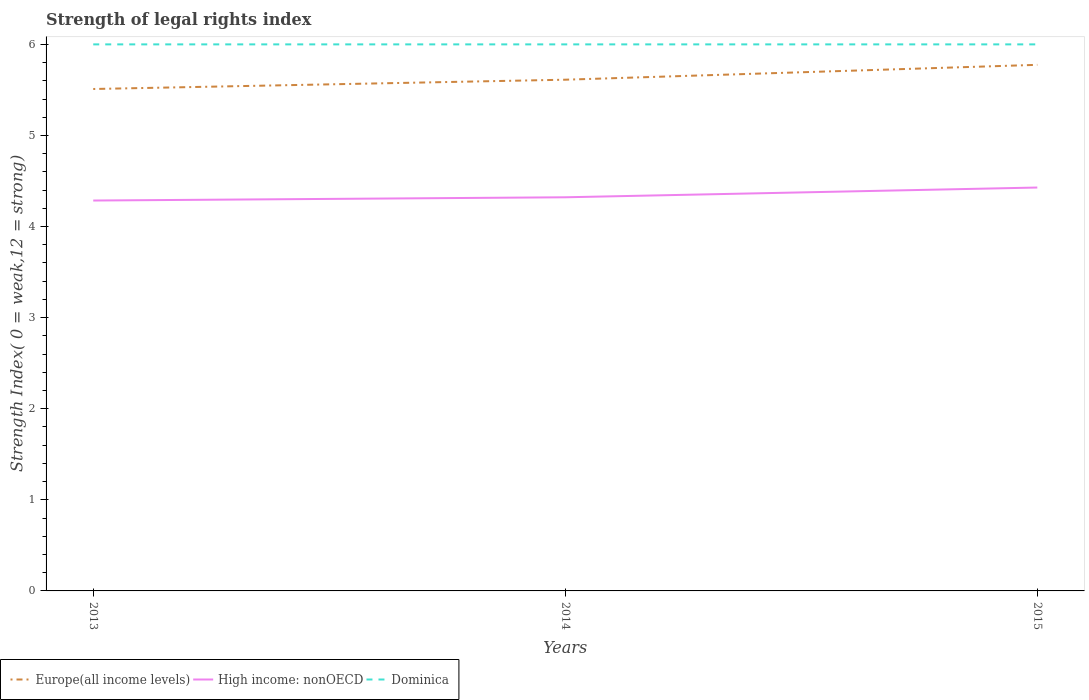Is the number of lines equal to the number of legend labels?
Your answer should be compact. Yes. Across all years, what is the maximum strength index in Europe(all income levels)?
Keep it short and to the point. 5.51. In which year was the strength index in Dominica maximum?
Provide a short and direct response. 2013. What is the total strength index in High income: nonOECD in the graph?
Your response must be concise. -0.04. What is the difference between the highest and the second highest strength index in High income: nonOECD?
Your answer should be very brief. 0.14. Is the strength index in Europe(all income levels) strictly greater than the strength index in High income: nonOECD over the years?
Provide a short and direct response. No. How many lines are there?
Your answer should be compact. 3. How many years are there in the graph?
Offer a very short reply. 3. Does the graph contain grids?
Offer a terse response. No. What is the title of the graph?
Your answer should be compact. Strength of legal rights index. What is the label or title of the X-axis?
Offer a terse response. Years. What is the label or title of the Y-axis?
Provide a succinct answer. Strength Index( 0 = weak,12 = strong). What is the Strength Index( 0 = weak,12 = strong) in Europe(all income levels) in 2013?
Offer a terse response. 5.51. What is the Strength Index( 0 = weak,12 = strong) in High income: nonOECD in 2013?
Your response must be concise. 4.29. What is the Strength Index( 0 = weak,12 = strong) in Europe(all income levels) in 2014?
Your answer should be compact. 5.61. What is the Strength Index( 0 = weak,12 = strong) in High income: nonOECD in 2014?
Your answer should be very brief. 4.32. What is the Strength Index( 0 = weak,12 = strong) in Europe(all income levels) in 2015?
Keep it short and to the point. 5.78. What is the Strength Index( 0 = weak,12 = strong) of High income: nonOECD in 2015?
Offer a very short reply. 4.43. What is the Strength Index( 0 = weak,12 = strong) of Dominica in 2015?
Give a very brief answer. 6. Across all years, what is the maximum Strength Index( 0 = weak,12 = strong) of Europe(all income levels)?
Offer a very short reply. 5.78. Across all years, what is the maximum Strength Index( 0 = weak,12 = strong) in High income: nonOECD?
Ensure brevity in your answer.  4.43. Across all years, what is the maximum Strength Index( 0 = weak,12 = strong) of Dominica?
Provide a short and direct response. 6. Across all years, what is the minimum Strength Index( 0 = weak,12 = strong) in Europe(all income levels)?
Keep it short and to the point. 5.51. Across all years, what is the minimum Strength Index( 0 = weak,12 = strong) in High income: nonOECD?
Your response must be concise. 4.29. Across all years, what is the minimum Strength Index( 0 = weak,12 = strong) of Dominica?
Offer a terse response. 6. What is the total Strength Index( 0 = weak,12 = strong) in Europe(all income levels) in the graph?
Provide a short and direct response. 16.9. What is the total Strength Index( 0 = weak,12 = strong) of High income: nonOECD in the graph?
Provide a short and direct response. 13.04. What is the total Strength Index( 0 = weak,12 = strong) of Dominica in the graph?
Your response must be concise. 18. What is the difference between the Strength Index( 0 = weak,12 = strong) in Europe(all income levels) in 2013 and that in 2014?
Offer a very short reply. -0.1. What is the difference between the Strength Index( 0 = weak,12 = strong) of High income: nonOECD in 2013 and that in 2014?
Offer a terse response. -0.04. What is the difference between the Strength Index( 0 = weak,12 = strong) of Europe(all income levels) in 2013 and that in 2015?
Provide a succinct answer. -0.27. What is the difference between the Strength Index( 0 = weak,12 = strong) of High income: nonOECD in 2013 and that in 2015?
Offer a very short reply. -0.14. What is the difference between the Strength Index( 0 = weak,12 = strong) in Dominica in 2013 and that in 2015?
Keep it short and to the point. 0. What is the difference between the Strength Index( 0 = weak,12 = strong) of Europe(all income levels) in 2014 and that in 2015?
Your answer should be compact. -0.16. What is the difference between the Strength Index( 0 = weak,12 = strong) of High income: nonOECD in 2014 and that in 2015?
Keep it short and to the point. -0.11. What is the difference between the Strength Index( 0 = weak,12 = strong) of Dominica in 2014 and that in 2015?
Give a very brief answer. 0. What is the difference between the Strength Index( 0 = weak,12 = strong) of Europe(all income levels) in 2013 and the Strength Index( 0 = weak,12 = strong) of High income: nonOECD in 2014?
Your response must be concise. 1.19. What is the difference between the Strength Index( 0 = weak,12 = strong) in Europe(all income levels) in 2013 and the Strength Index( 0 = weak,12 = strong) in Dominica in 2014?
Your response must be concise. -0.49. What is the difference between the Strength Index( 0 = weak,12 = strong) of High income: nonOECD in 2013 and the Strength Index( 0 = weak,12 = strong) of Dominica in 2014?
Offer a terse response. -1.71. What is the difference between the Strength Index( 0 = weak,12 = strong) in Europe(all income levels) in 2013 and the Strength Index( 0 = weak,12 = strong) in High income: nonOECD in 2015?
Provide a short and direct response. 1.08. What is the difference between the Strength Index( 0 = weak,12 = strong) of Europe(all income levels) in 2013 and the Strength Index( 0 = weak,12 = strong) of Dominica in 2015?
Your response must be concise. -0.49. What is the difference between the Strength Index( 0 = weak,12 = strong) in High income: nonOECD in 2013 and the Strength Index( 0 = weak,12 = strong) in Dominica in 2015?
Offer a terse response. -1.71. What is the difference between the Strength Index( 0 = weak,12 = strong) of Europe(all income levels) in 2014 and the Strength Index( 0 = weak,12 = strong) of High income: nonOECD in 2015?
Keep it short and to the point. 1.18. What is the difference between the Strength Index( 0 = weak,12 = strong) in Europe(all income levels) in 2014 and the Strength Index( 0 = weak,12 = strong) in Dominica in 2015?
Your response must be concise. -0.39. What is the difference between the Strength Index( 0 = weak,12 = strong) in High income: nonOECD in 2014 and the Strength Index( 0 = weak,12 = strong) in Dominica in 2015?
Offer a terse response. -1.68. What is the average Strength Index( 0 = weak,12 = strong) in Europe(all income levels) per year?
Your answer should be very brief. 5.63. What is the average Strength Index( 0 = weak,12 = strong) of High income: nonOECD per year?
Provide a short and direct response. 4.35. In the year 2013, what is the difference between the Strength Index( 0 = weak,12 = strong) of Europe(all income levels) and Strength Index( 0 = weak,12 = strong) of High income: nonOECD?
Make the answer very short. 1.22. In the year 2013, what is the difference between the Strength Index( 0 = weak,12 = strong) in Europe(all income levels) and Strength Index( 0 = weak,12 = strong) in Dominica?
Make the answer very short. -0.49. In the year 2013, what is the difference between the Strength Index( 0 = weak,12 = strong) in High income: nonOECD and Strength Index( 0 = weak,12 = strong) in Dominica?
Your response must be concise. -1.71. In the year 2014, what is the difference between the Strength Index( 0 = weak,12 = strong) in Europe(all income levels) and Strength Index( 0 = weak,12 = strong) in High income: nonOECD?
Keep it short and to the point. 1.29. In the year 2014, what is the difference between the Strength Index( 0 = weak,12 = strong) in Europe(all income levels) and Strength Index( 0 = weak,12 = strong) in Dominica?
Provide a succinct answer. -0.39. In the year 2014, what is the difference between the Strength Index( 0 = weak,12 = strong) in High income: nonOECD and Strength Index( 0 = weak,12 = strong) in Dominica?
Provide a succinct answer. -1.68. In the year 2015, what is the difference between the Strength Index( 0 = weak,12 = strong) of Europe(all income levels) and Strength Index( 0 = weak,12 = strong) of High income: nonOECD?
Your response must be concise. 1.35. In the year 2015, what is the difference between the Strength Index( 0 = weak,12 = strong) of Europe(all income levels) and Strength Index( 0 = weak,12 = strong) of Dominica?
Provide a short and direct response. -0.22. In the year 2015, what is the difference between the Strength Index( 0 = weak,12 = strong) of High income: nonOECD and Strength Index( 0 = weak,12 = strong) of Dominica?
Ensure brevity in your answer.  -1.57. What is the ratio of the Strength Index( 0 = weak,12 = strong) in Europe(all income levels) in 2013 to that in 2014?
Make the answer very short. 0.98. What is the ratio of the Strength Index( 0 = weak,12 = strong) of High income: nonOECD in 2013 to that in 2014?
Offer a very short reply. 0.99. What is the ratio of the Strength Index( 0 = weak,12 = strong) of Europe(all income levels) in 2013 to that in 2015?
Ensure brevity in your answer.  0.95. What is the ratio of the Strength Index( 0 = weak,12 = strong) of High income: nonOECD in 2013 to that in 2015?
Provide a short and direct response. 0.97. What is the ratio of the Strength Index( 0 = weak,12 = strong) in Dominica in 2013 to that in 2015?
Offer a very short reply. 1. What is the ratio of the Strength Index( 0 = weak,12 = strong) in Europe(all income levels) in 2014 to that in 2015?
Make the answer very short. 0.97. What is the ratio of the Strength Index( 0 = weak,12 = strong) in High income: nonOECD in 2014 to that in 2015?
Make the answer very short. 0.98. What is the difference between the highest and the second highest Strength Index( 0 = weak,12 = strong) of Europe(all income levels)?
Provide a succinct answer. 0.16. What is the difference between the highest and the second highest Strength Index( 0 = weak,12 = strong) in High income: nonOECD?
Your answer should be compact. 0.11. What is the difference between the highest and the lowest Strength Index( 0 = weak,12 = strong) of Europe(all income levels)?
Ensure brevity in your answer.  0.27. What is the difference between the highest and the lowest Strength Index( 0 = weak,12 = strong) in High income: nonOECD?
Provide a short and direct response. 0.14. What is the difference between the highest and the lowest Strength Index( 0 = weak,12 = strong) in Dominica?
Your response must be concise. 0. 